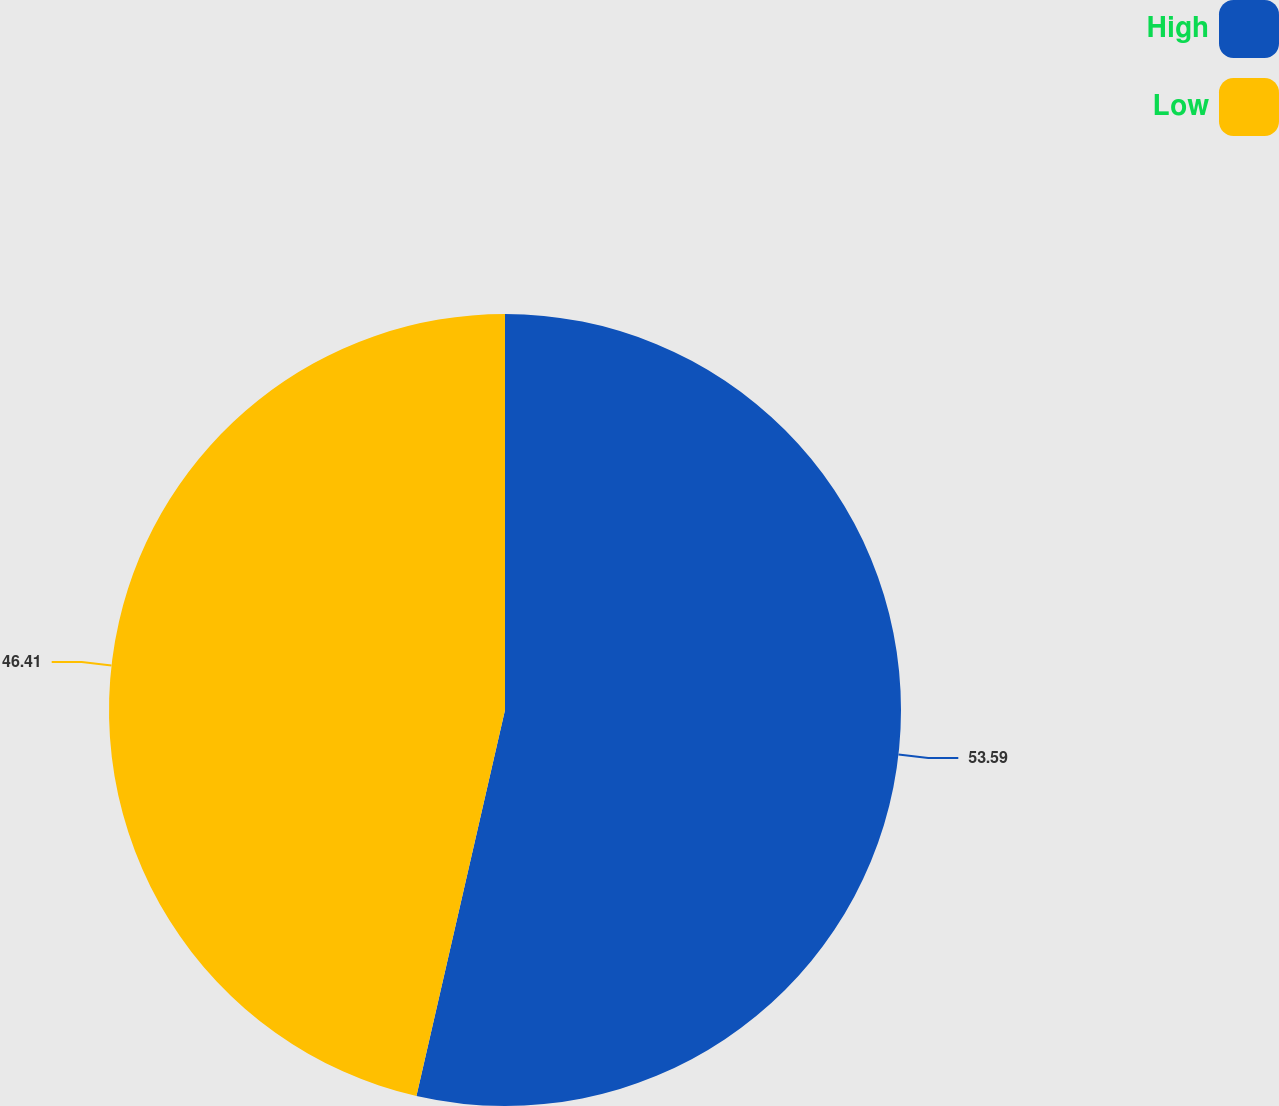<chart> <loc_0><loc_0><loc_500><loc_500><pie_chart><fcel>High<fcel>Low<nl><fcel>53.59%<fcel>46.41%<nl></chart> 